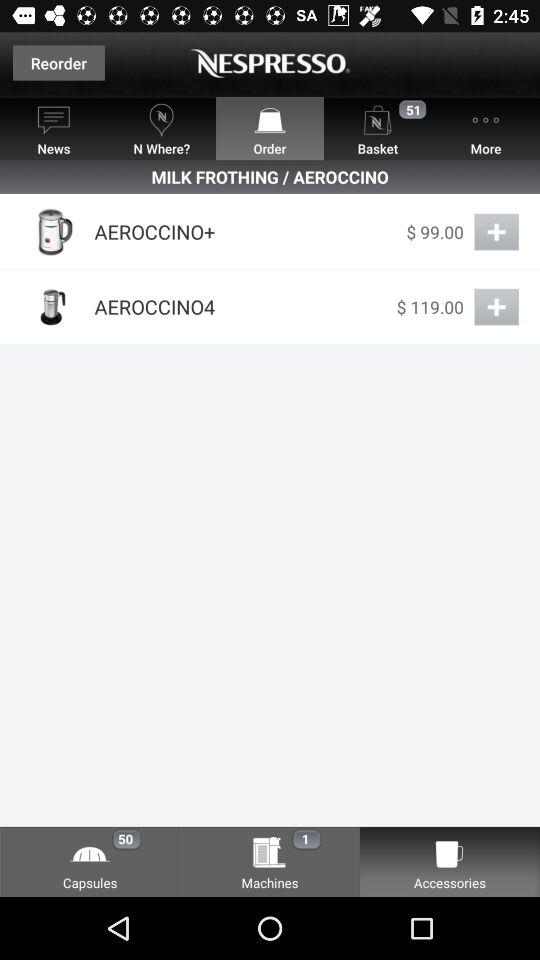How much more does the AEROCTINO4 cost than the AEROCTINO+?
Answer the question using a single word or phrase. $20.00 